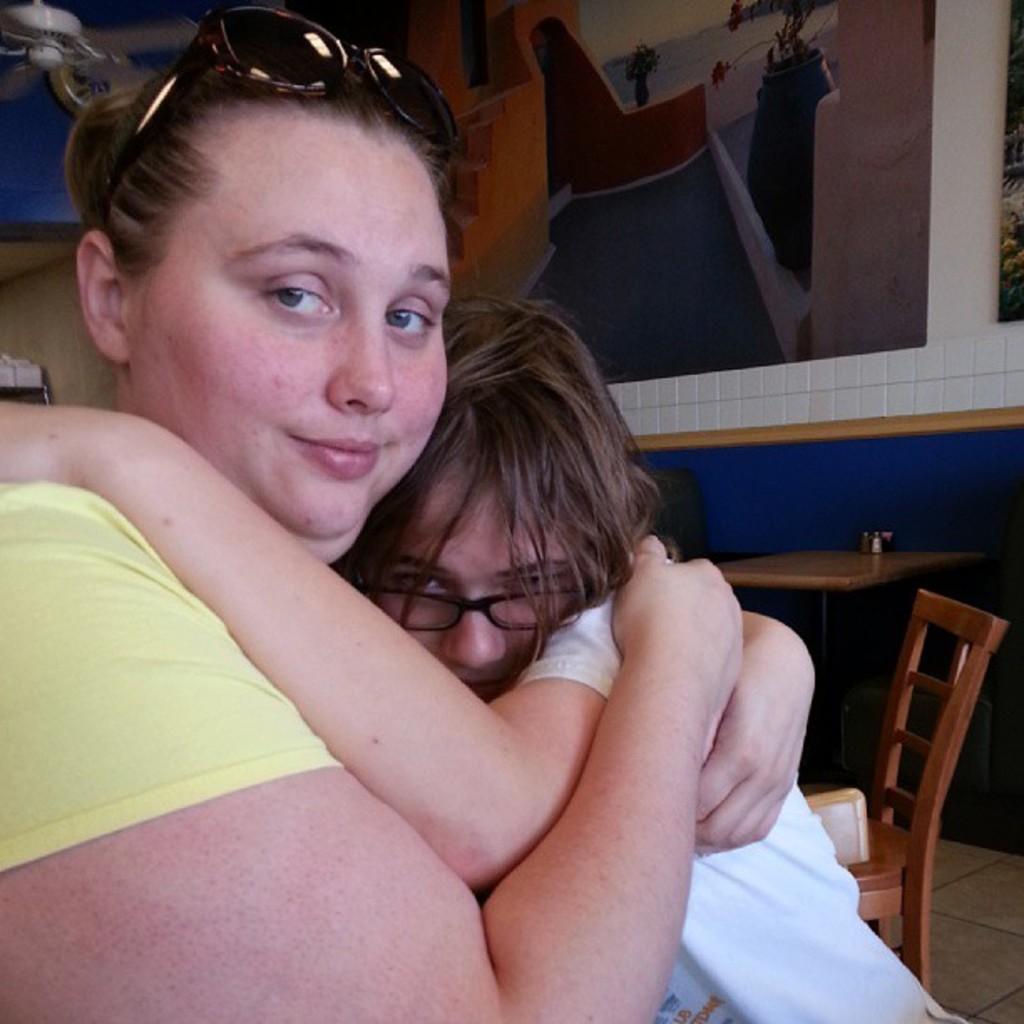In one or two sentences, can you explain what this image depicts? In this picture does a woman hugging a girl. In the background there is wall, frames, table and chair. In the frame there is staircase, plant, flower vase, water and sky. 